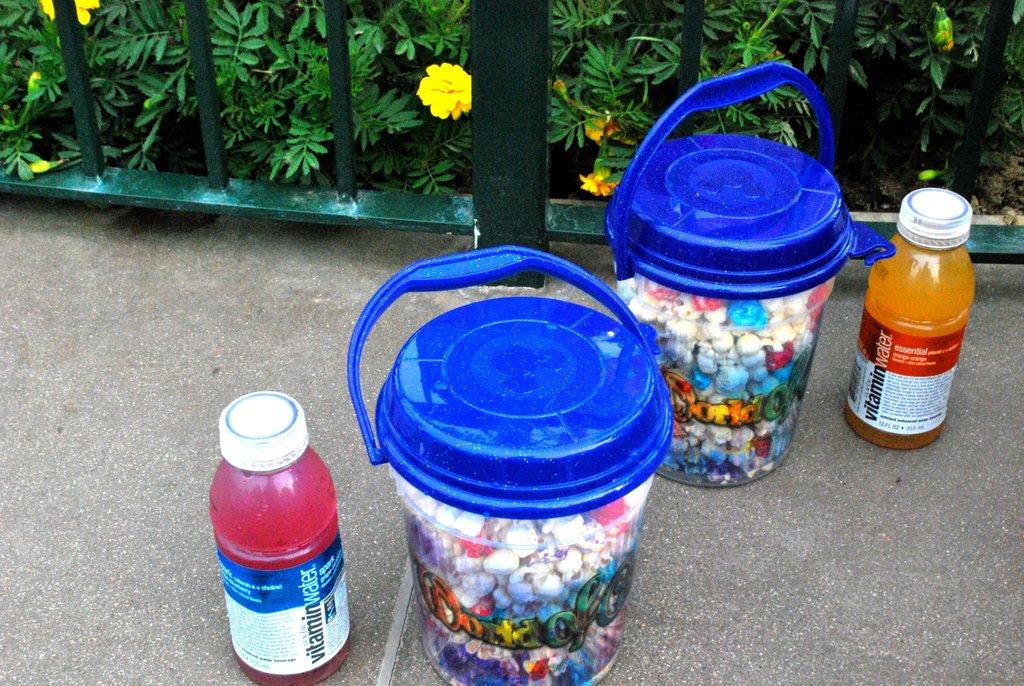What is the name of the drinks in the picture?
Give a very brief answer. Vitamin water. What does the white text on the bottom label say in the blue section?
Your answer should be very brief. Vitamin. 